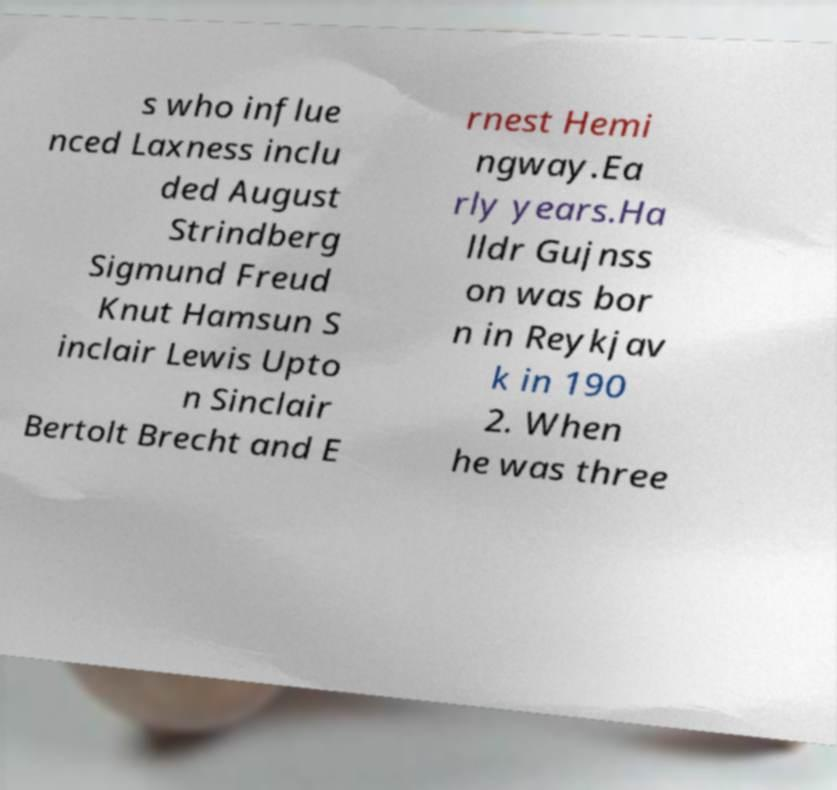What messages or text are displayed in this image? I need them in a readable, typed format. s who influe nced Laxness inclu ded August Strindberg Sigmund Freud Knut Hamsun S inclair Lewis Upto n Sinclair Bertolt Brecht and E rnest Hemi ngway.Ea rly years.Ha lldr Gujnss on was bor n in Reykjav k in 190 2. When he was three 